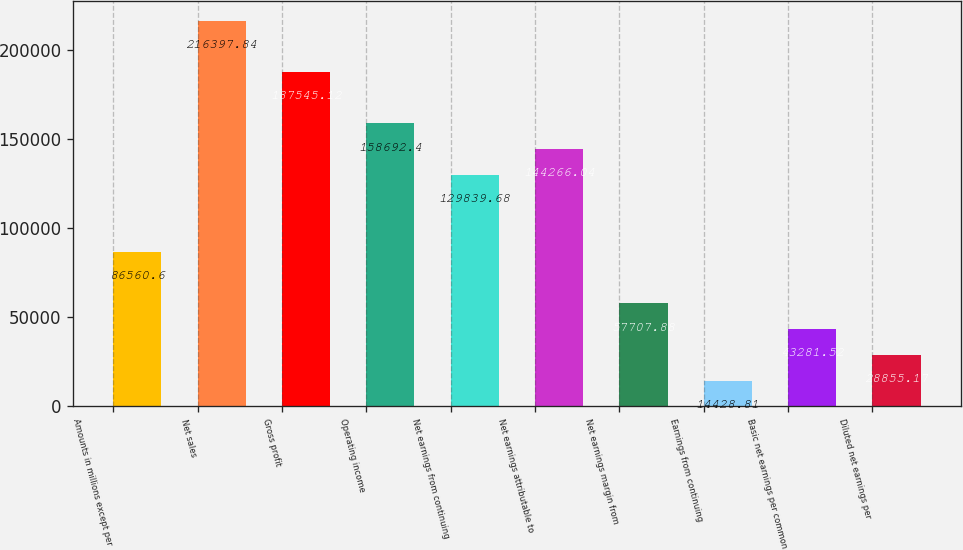Convert chart. <chart><loc_0><loc_0><loc_500><loc_500><bar_chart><fcel>Amounts in millions except per<fcel>Net sales<fcel>Gross profit<fcel>Operating income<fcel>Net earnings from continuing<fcel>Net earnings attributable to<fcel>Net earnings margin from<fcel>Earnings from continuing<fcel>Basic net earnings per common<fcel>Diluted net earnings per<nl><fcel>86560.6<fcel>216398<fcel>187545<fcel>158692<fcel>129840<fcel>144266<fcel>57707.9<fcel>14428.8<fcel>43281.5<fcel>28855.2<nl></chart> 